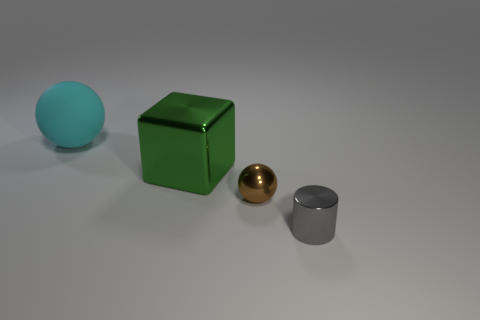How many cubes are either brown shiny objects or cyan rubber things?
Ensure brevity in your answer.  0. What size is the sphere on the right side of the object to the left of the metal thing that is behind the small metal sphere?
Give a very brief answer. Small. The green object that is the same size as the cyan rubber ball is what shape?
Provide a succinct answer. Cube. What is the shape of the matte object?
Your answer should be very brief. Sphere. Is the material of the tiny thing to the left of the tiny gray metallic thing the same as the large green object?
Provide a short and direct response. Yes. There is a metallic thing behind the sphere that is in front of the large green metallic object; what is its size?
Your answer should be compact. Large. There is a metallic object that is both on the right side of the big green shiny cube and behind the shiny cylinder; what is its color?
Offer a terse response. Brown. There is another thing that is the same size as the green metallic thing; what material is it?
Offer a very short reply. Rubber. How many other objects are the same material as the big cyan object?
Your answer should be very brief. 0. The small metal thing in front of the tiny shiny object behind the small cylinder is what shape?
Keep it short and to the point. Cylinder. 